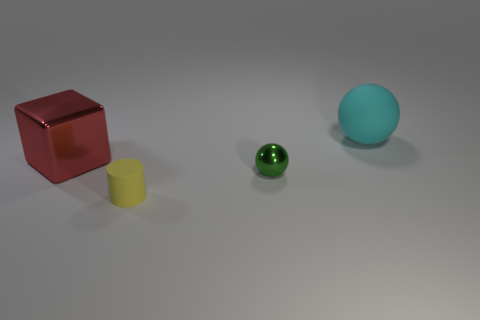Are there any small green objects to the right of the metallic thing that is on the right side of the yellow thing? no 